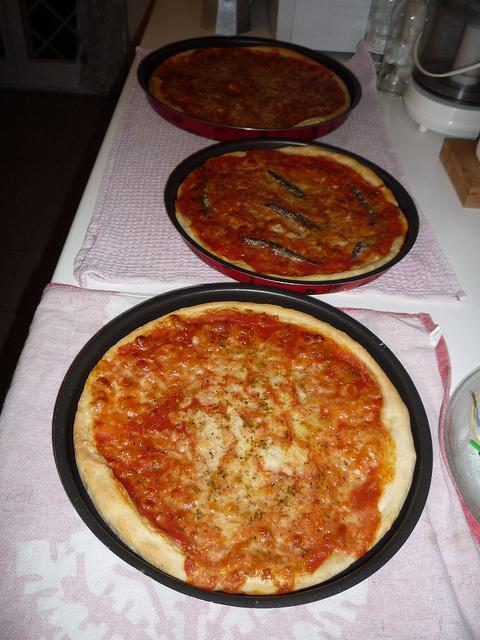What is the largest pizza on top of? towel 